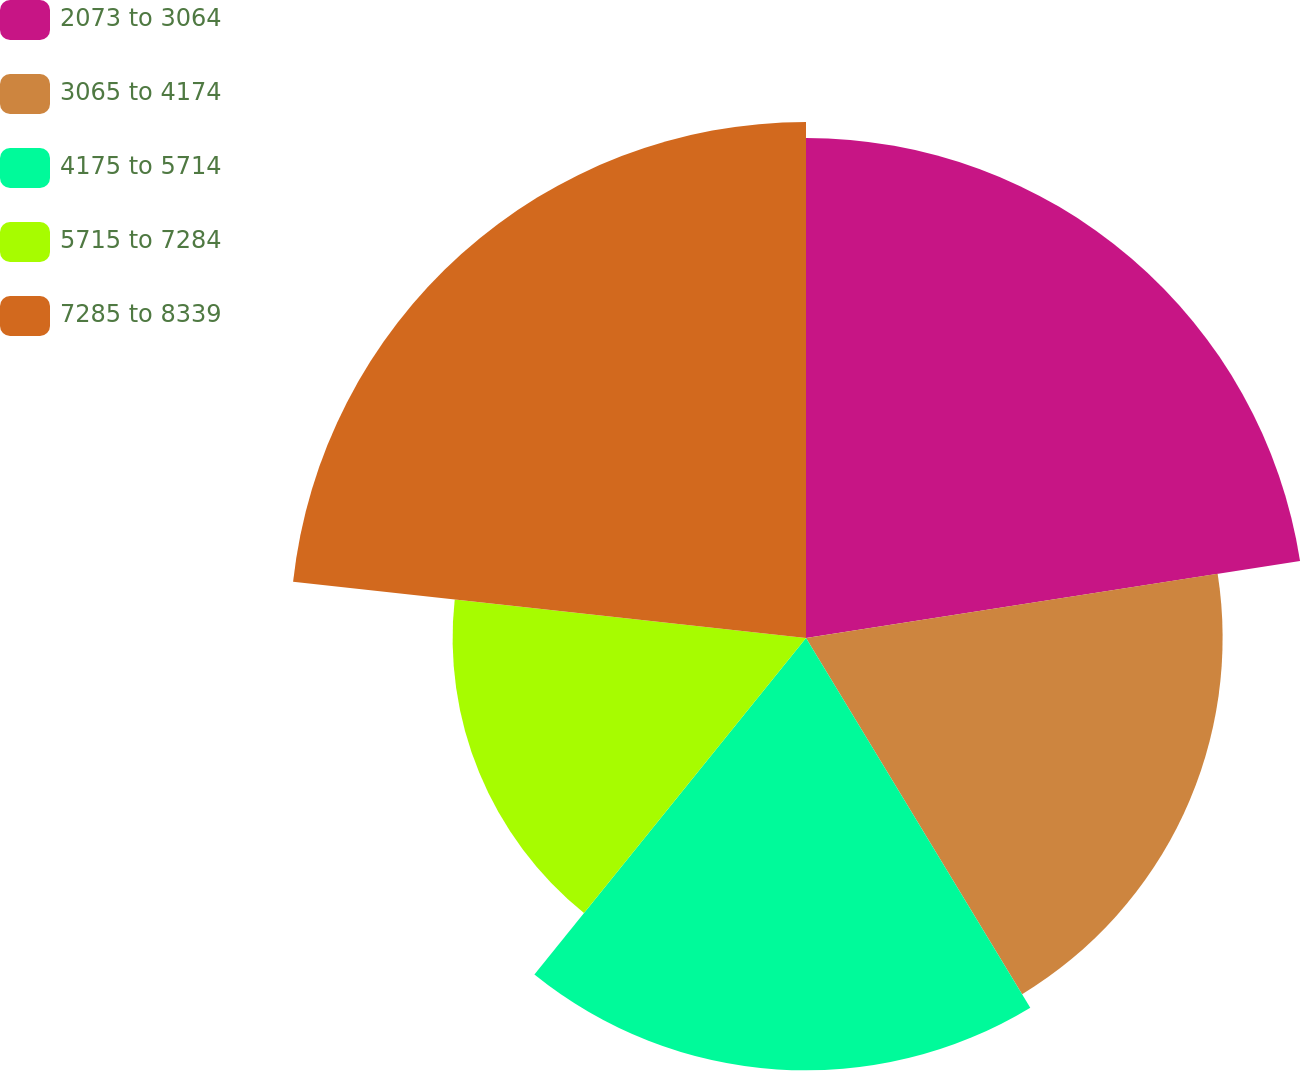Convert chart to OTSL. <chart><loc_0><loc_0><loc_500><loc_500><pie_chart><fcel>2073 to 3064<fcel>3065 to 4174<fcel>4175 to 5714<fcel>5715 to 7284<fcel>7285 to 8339<nl><fcel>22.54%<fcel>18.78%<fcel>19.49%<fcel>15.93%<fcel>23.26%<nl></chart> 